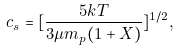Convert formula to latex. <formula><loc_0><loc_0><loc_500><loc_500>c _ { s } = [ \frac { 5 k T } { 3 \mu m _ { p } ( 1 + X ) } ] ^ { 1 / 2 } ,</formula> 